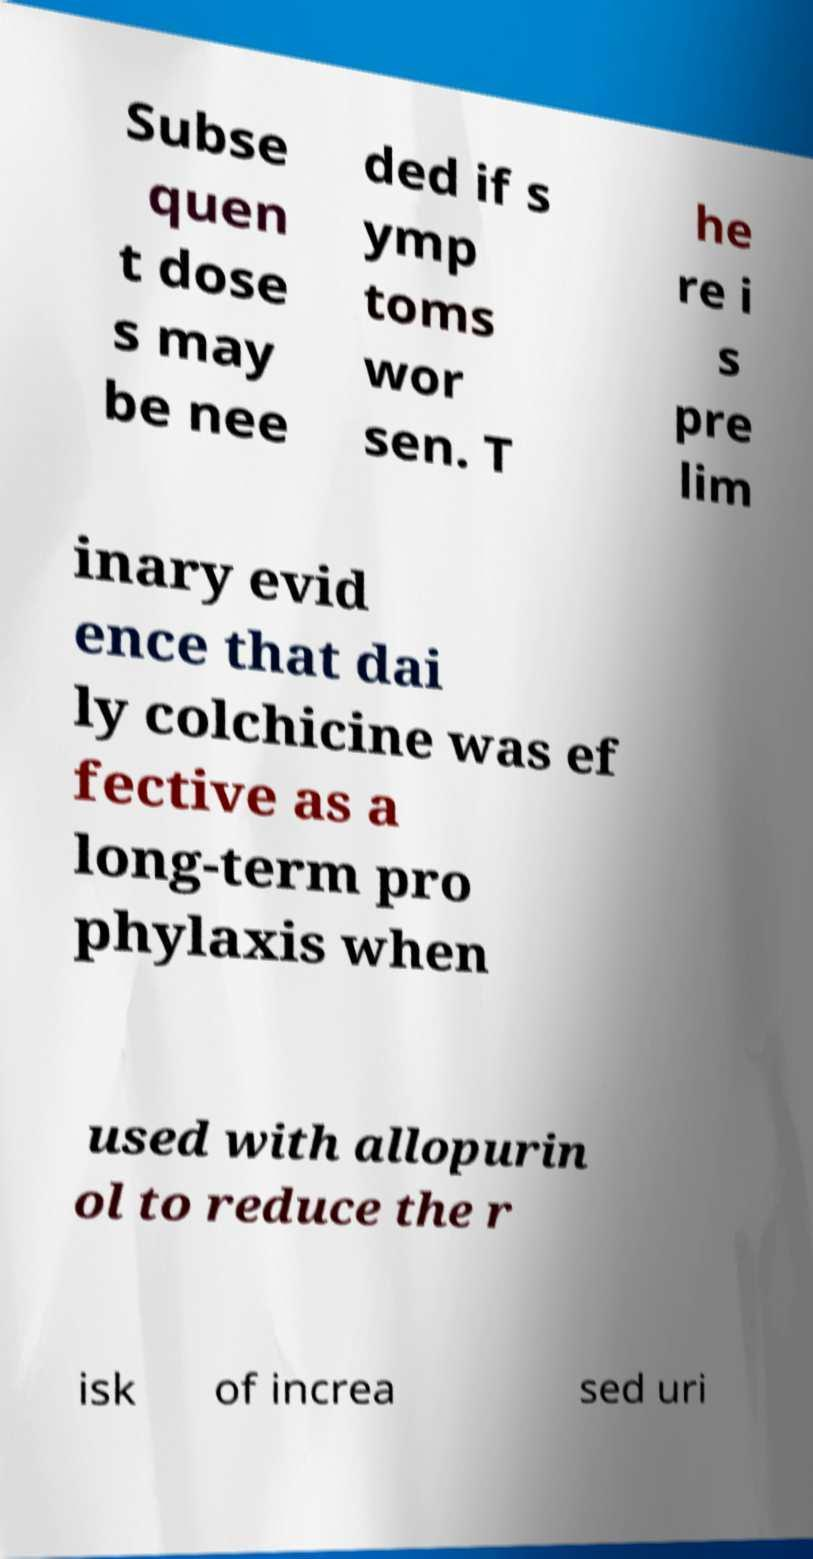I need the written content from this picture converted into text. Can you do that? Subse quen t dose s may be nee ded if s ymp toms wor sen. T he re i s pre lim inary evid ence that dai ly colchicine was ef fective as a long-term pro phylaxis when used with allopurin ol to reduce the r isk of increa sed uri 